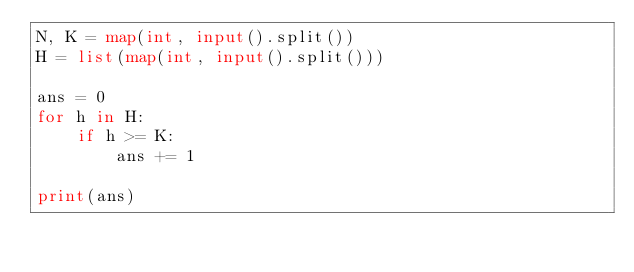Convert code to text. <code><loc_0><loc_0><loc_500><loc_500><_Python_>N, K = map(int, input().split())
H = list(map(int, input().split()))

ans = 0
for h in H:
    if h >= K:
        ans += 1

print(ans)
</code> 